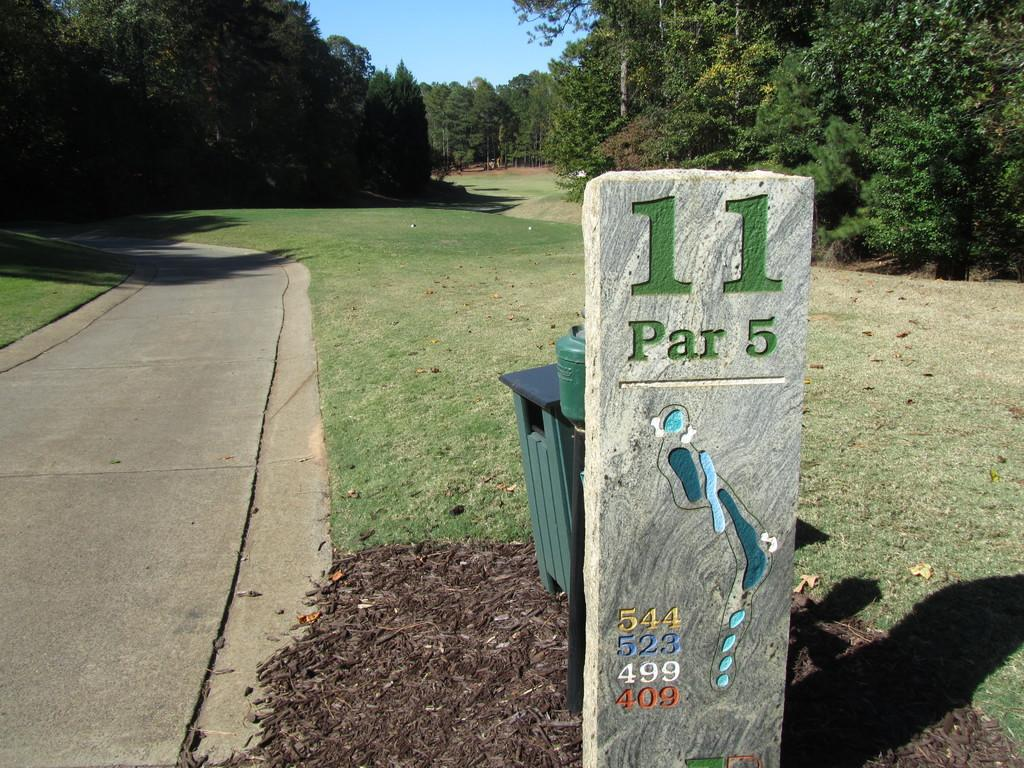<image>
Describe the image concisely. The path block shows this is 11 PAR 5 